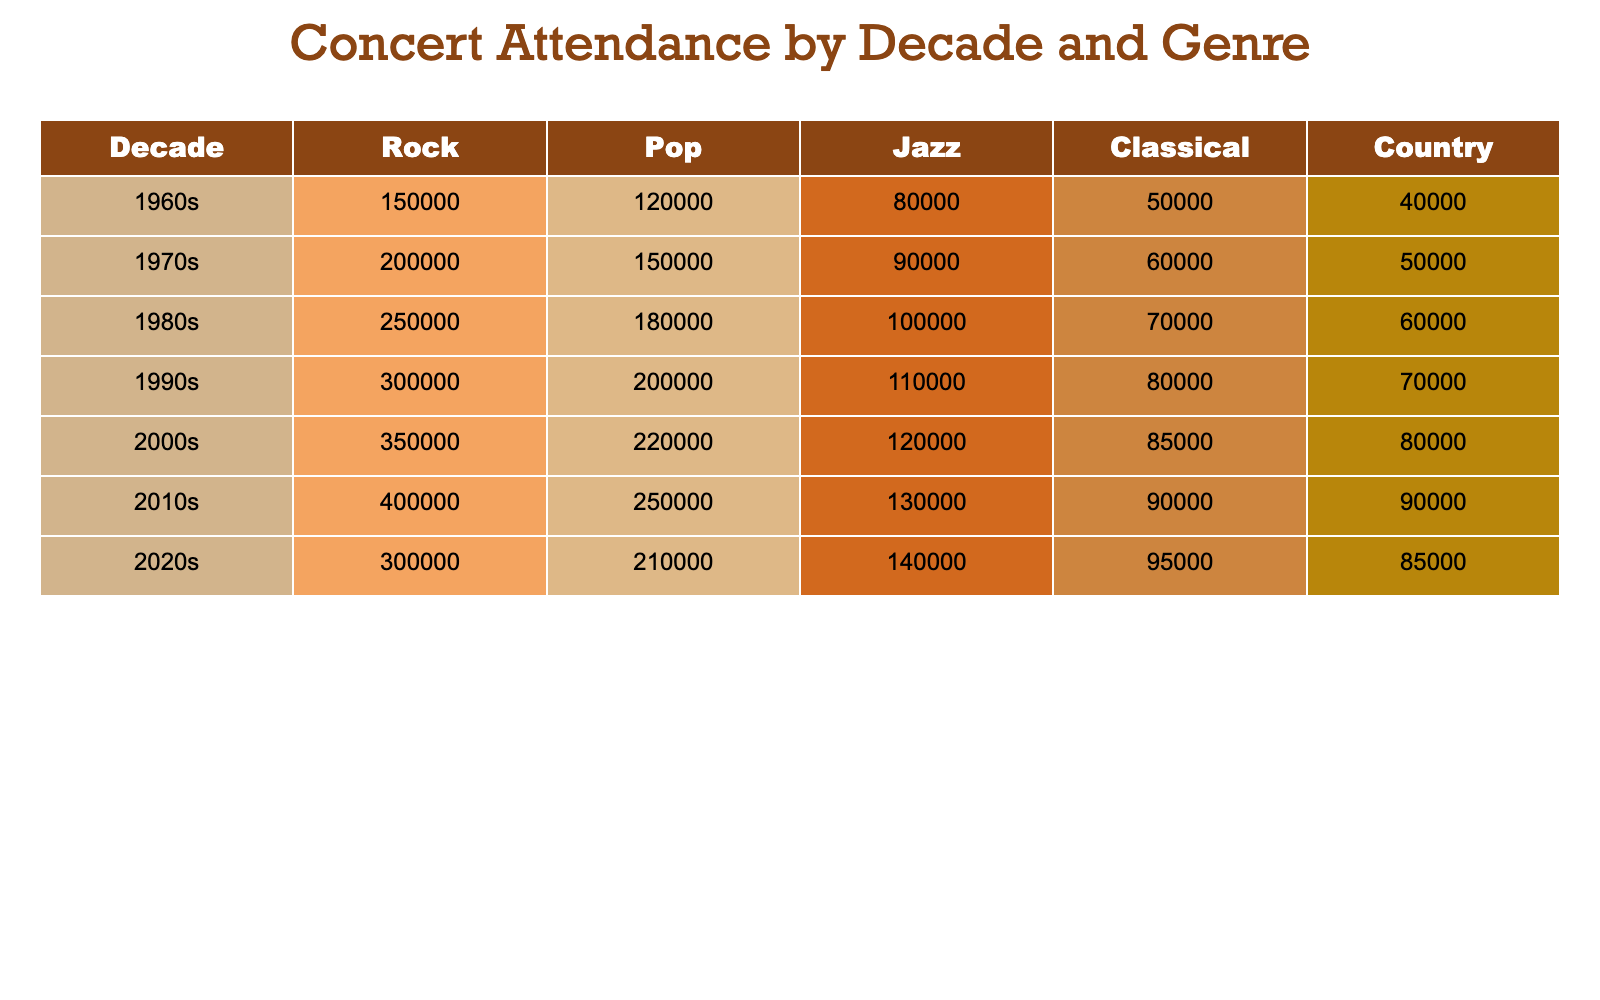What decade had the highest concert attendance for Rock music? To find the highest attendance for Rock music, we look at the Rock column across all decades. The attendance figures are: 150000 (1960s), 200000 (1970s), 250000 (1980s), 300000 (1990s), 350000 (2000s), and 400000 (2010s). The maximum value is 400000 in the 2010s.
Answer: 2010s Which genre had the lowest attendance in the 1980s? In the 1980s, the attendance figures for each genre are: Rock (250000), Pop (180000), Jazz (100000), Classical (70000), and Country (60000). The lowest attendance is found in the Country genre with 60000.
Answer: Country What is the total attendance for all genres in the 1990s? To find the total attendance for the 1990s, we sum the figures for each genre: Rock (300000) + Pop (200000) + Jazz (110000) + Classical (80000) + Country (70000) = 300000 + 200000 + 110000 + 80000 + 70000 = 870000.
Answer: 870000 Did the attendance for Pop music increase from the 1960s to the 1970s? The attendance for Pop music in the 1960s was 120000 and in the 1970s was 150000. Since 150000 is greater than 120000, this indicates an increase.
Answer: Yes Which genre had the highest attendance in the 2000s and what was its value? Looking at the 2000s, the attendance figures are Rock (350000), Pop (220000), Jazz (120000), Classical (85000), and Country (80000). The highest value is found in the Rock genre at 350000.
Answer: Rock, 350000 What decade had the greatest difference in attendance between Jazz and Pop? To determine the decade with the greatest difference between Jazz and Pop, we calculate the differences for each decade: 1960s: 120000 - 80000 = 40000, 1970s: 150000 - 90000 = 60000, 1980s: 180000 - 100000 = 80000, 1990s: 200000 - 110000 = 90000, 2000s: 220000 - 120000 = 100000, 2010s: 250000 - 130000 = 120000, and 2020s: 210000 - 140000 = 70000. The greatest difference is 120000 in the 2010s.
Answer: 2010s What was the average attendance for Classical music across all decades? We find the total attendance for Classical music: 50000 (1960s) + 60000 (1970s) + 70000 (1980s) + 80000 (1990s) + 85000 (2000s) + 90000 (2010s) + 95000 (2020s) = 450000. There are 7 decades, so the average is 450000 / 7 ≈ 64285.71.
Answer: Approximately 64286 Which genre saw the highest increase in attendance from the 2000s to the 2010s? We calculate the attendance increase for each genre from the 2000s to the 2010s: Rock (400000 - 350000 = 50000), Pop (250000 - 220000 = 30000), Jazz (130000 - 120000 = 10000), Classical (90000 - 85000 = 5000), and Country (90000 - 80000 = 10000). The highest increase is in Rock with 50000.
Answer: Rock, 50000 